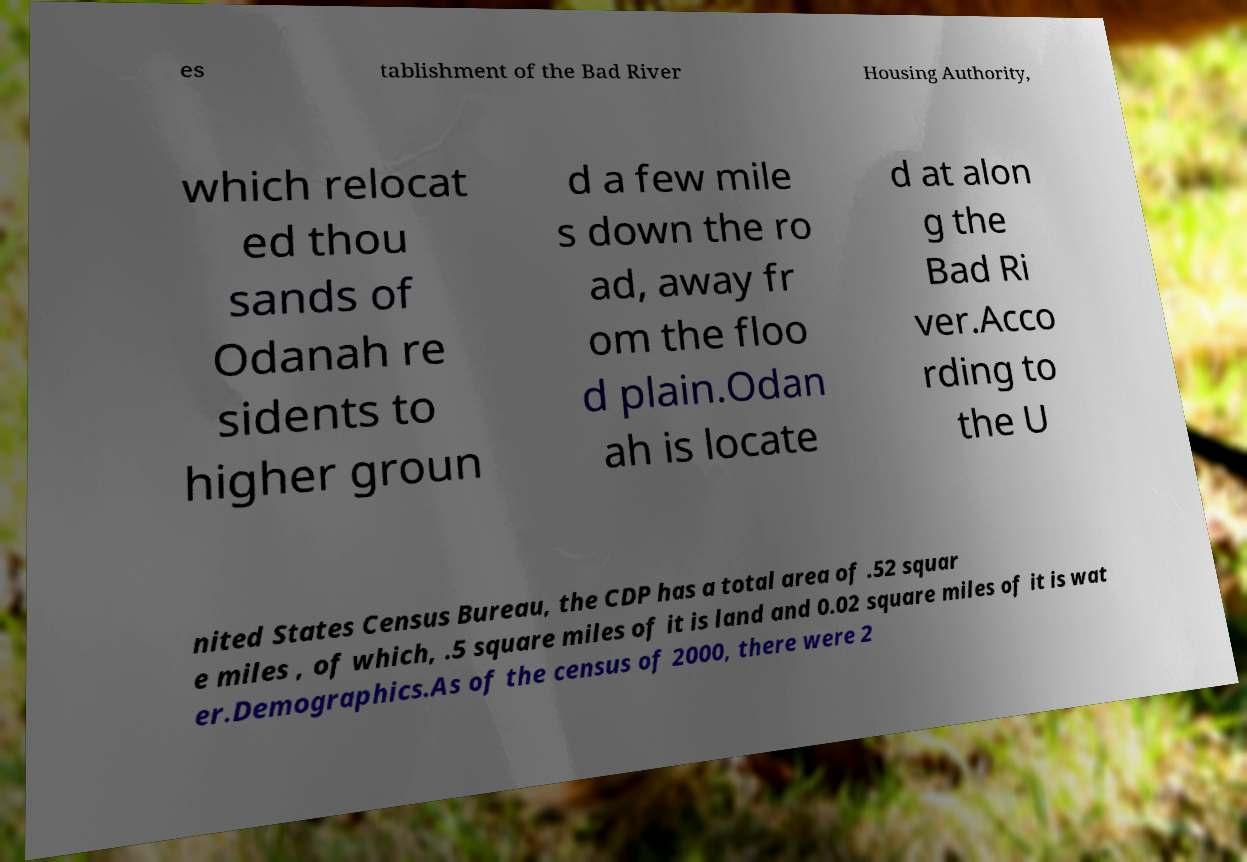There's text embedded in this image that I need extracted. Can you transcribe it verbatim? es tablishment of the Bad River Housing Authority, which relocat ed thou sands of Odanah re sidents to higher groun d a few mile s down the ro ad, away fr om the floo d plain.Odan ah is locate d at alon g the Bad Ri ver.Acco rding to the U nited States Census Bureau, the CDP has a total area of .52 squar e miles , of which, .5 square miles of it is land and 0.02 square miles of it is wat er.Demographics.As of the census of 2000, there were 2 